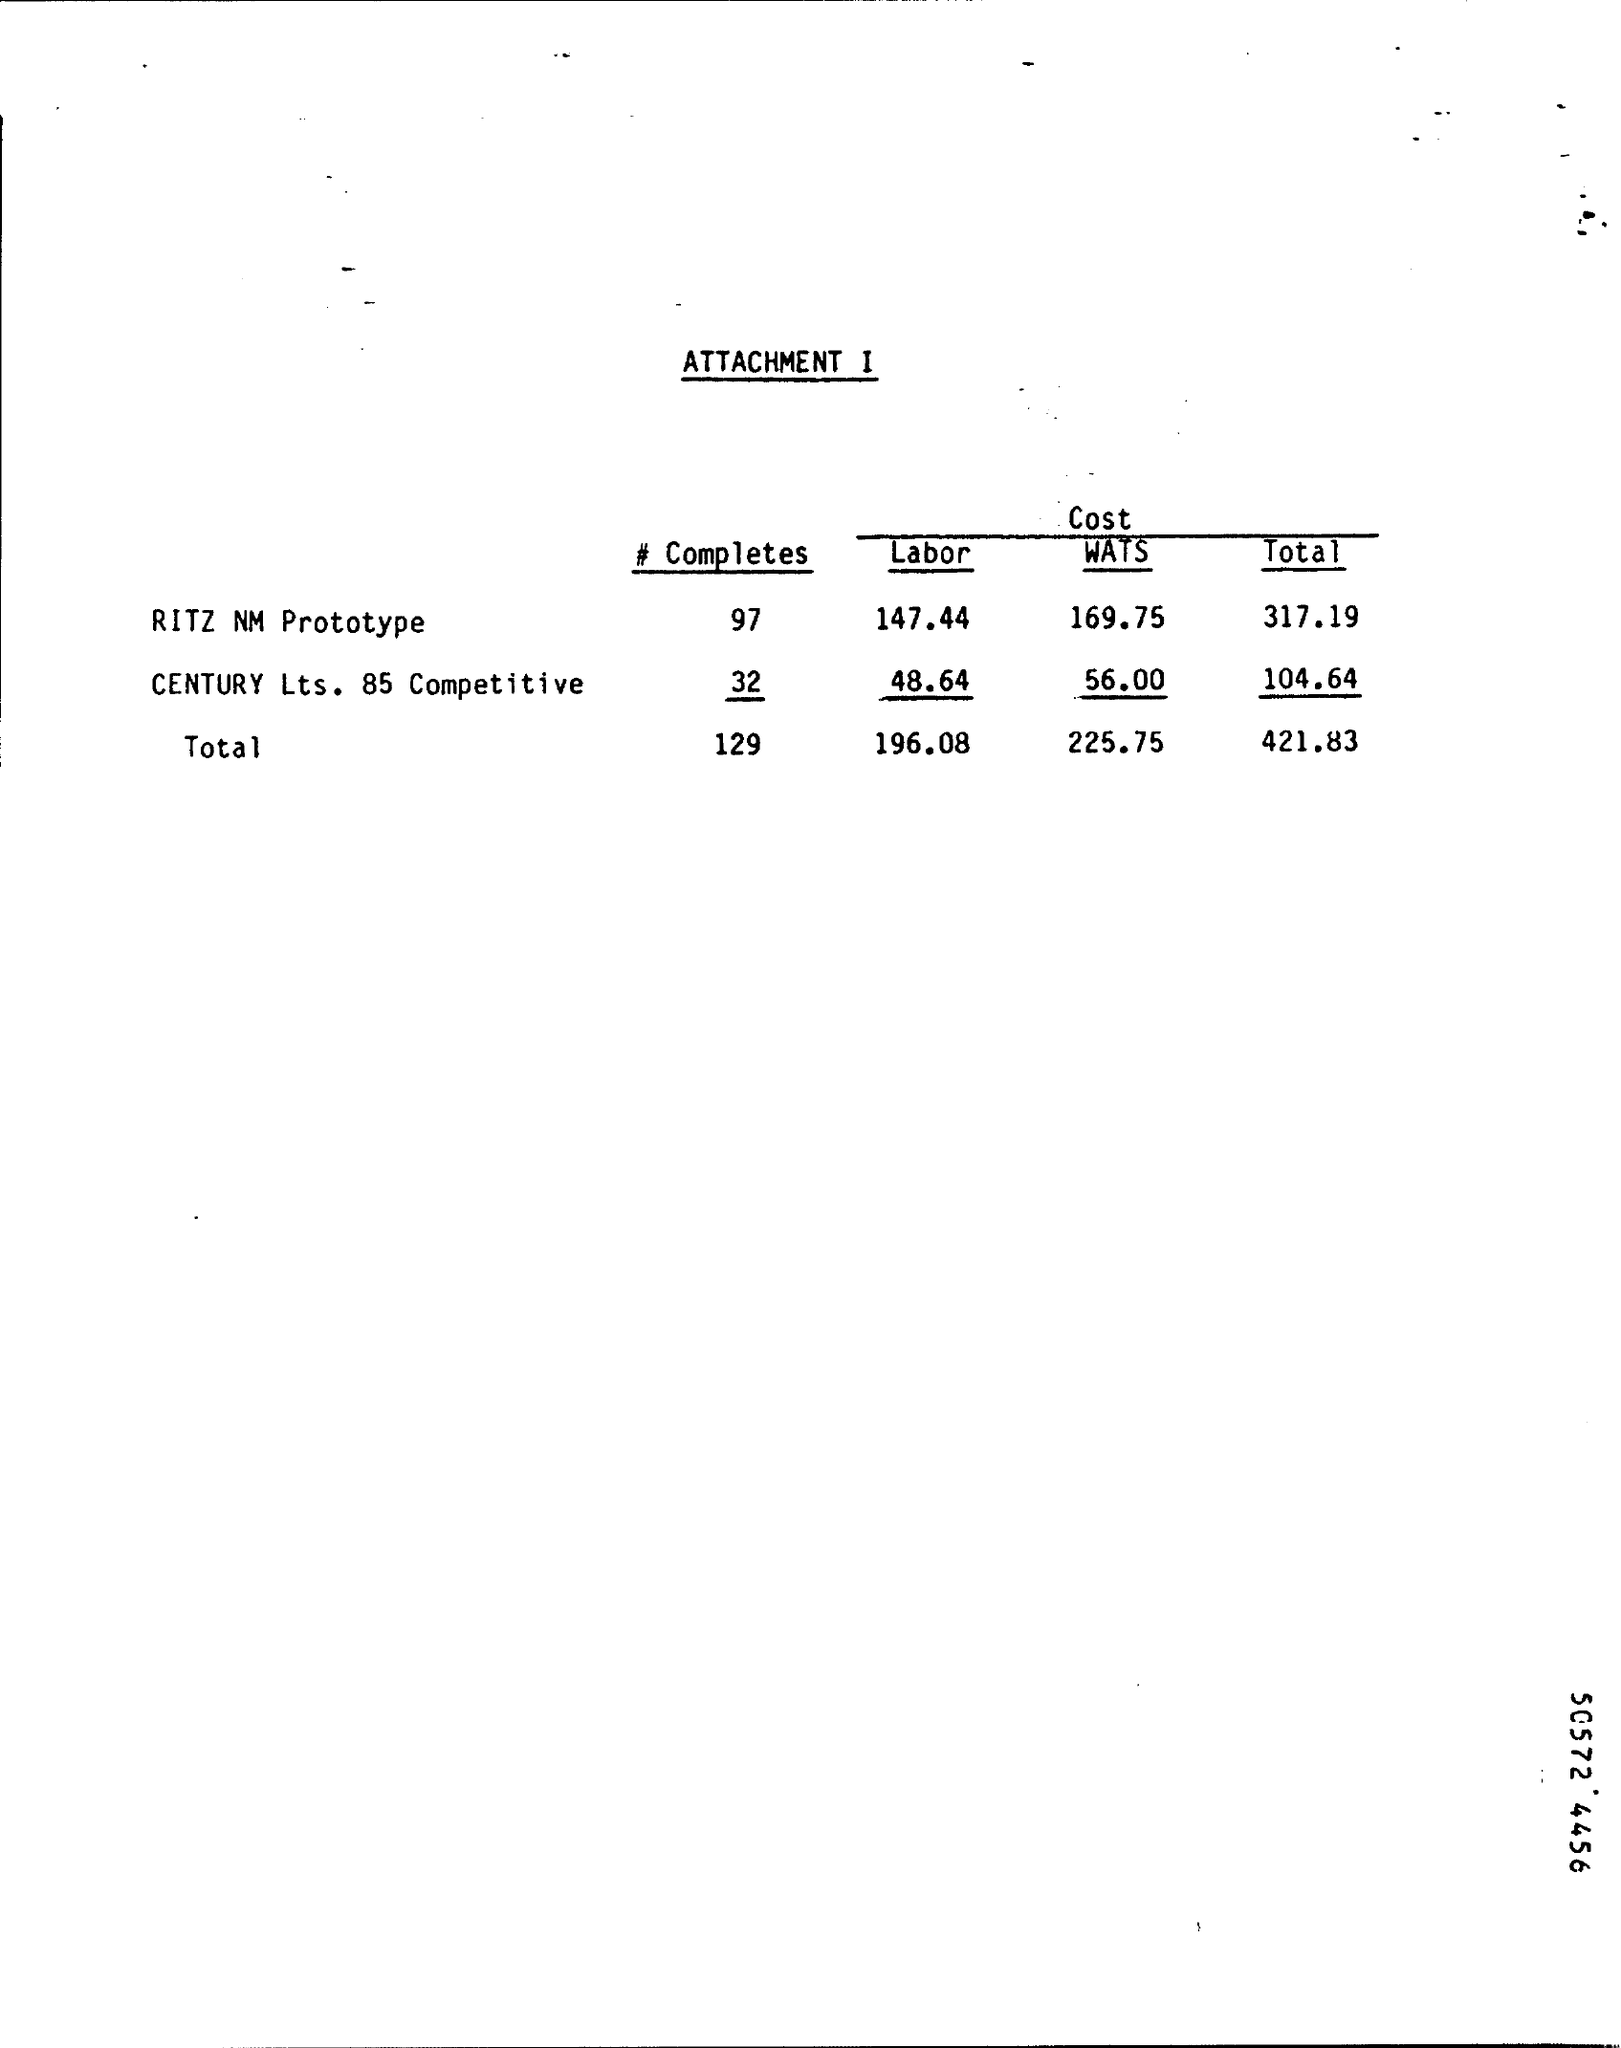Outline some significant characteristics in this image. The total cost for Century Lts. 85 Competitive is approximately 104.64 dollars. The cost of the WATS for the RITZ NM Prototype is 169.75. The sum total of all the costs is 421.83. The cost of the WATS service for Century Lts. 85 Competitive is 56.00. The total cost for the RITZ NM Prototype is 317.19. 